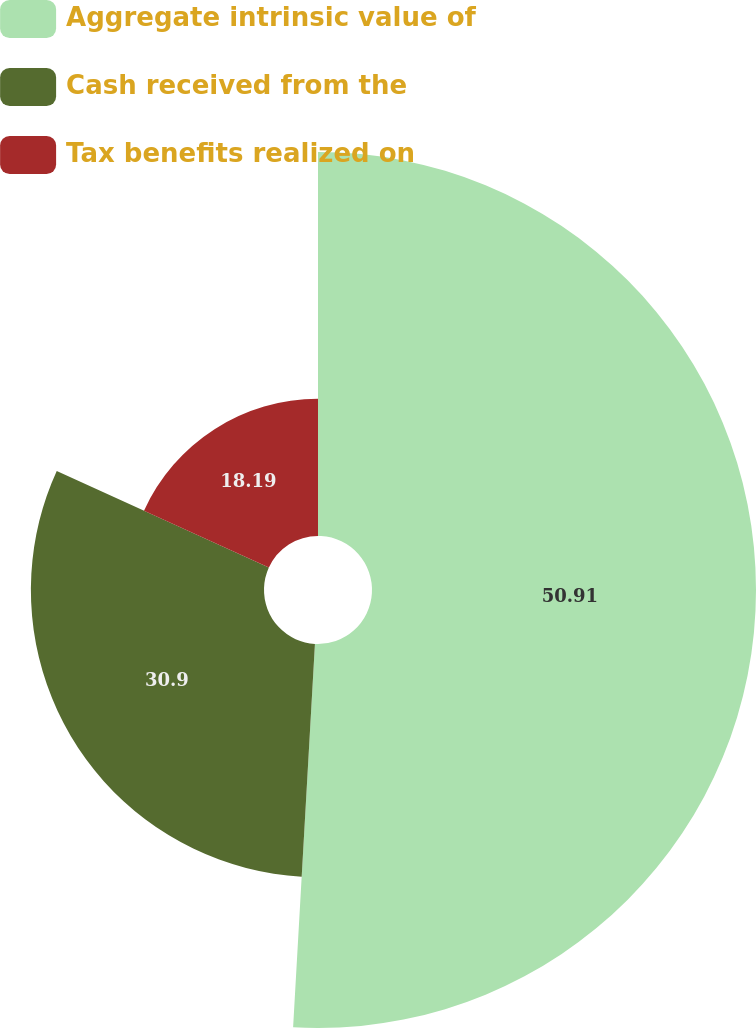<chart> <loc_0><loc_0><loc_500><loc_500><pie_chart><fcel>Aggregate intrinsic value of<fcel>Cash received from the<fcel>Tax benefits realized on<nl><fcel>50.9%<fcel>30.9%<fcel>18.19%<nl></chart> 